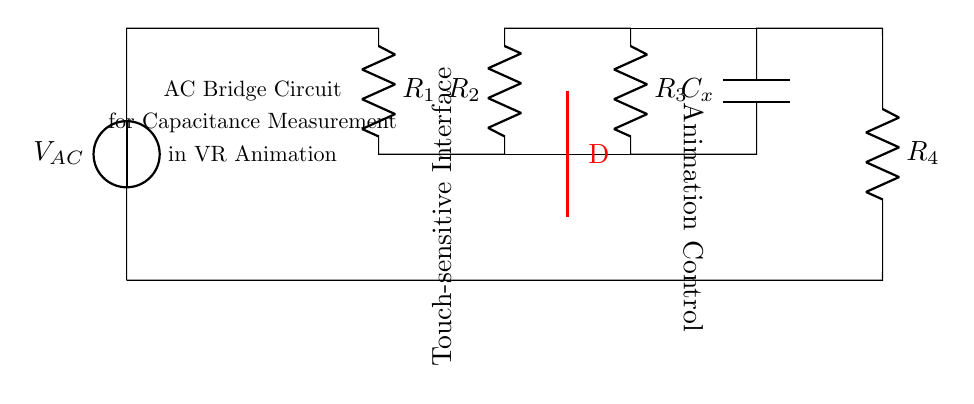What is the function of C_x in this circuit? C_x represents the capacitor being measured, and its value affects the balance of the bridge circuit, enabling capacitance measurement.
Answer: capacitor What is the total number of resistors in this bridge circuit? There are four resistors (R_1, R_2, R_3, R_4) in this circuit that are critical for creating the AC bridge configuration needed for capacitance measurement.
Answer: four Which components are involved in the animation control section? The components linked to the animation control involve the R_3 resistor and the connections above to the capacitor. They are responsible for managing how changes in capacitance affect the animation interface.
Answer: R_3 and C_x What is indicated by the label "D" in the diagram? The label "D" indicates a position in the circuit where the output or signal can be monitored or measured, specifically for touch-sensitive input in the circuit structure.
Answer: output position How many total nodes are there in the circuit? The circuit diagram shows a total of seven nodes: two at each resistor terminal, two at the capacitor terminal, and one at the AC source. This indicates multiple connection points for component interactions.
Answer: seven What type of current does this circuit use? The circuit is powered by alternating current (AC), as indicated by the voltage source labeled V_AC, which is meant for AC applications such as this bridge configuration.
Answer: alternating current 